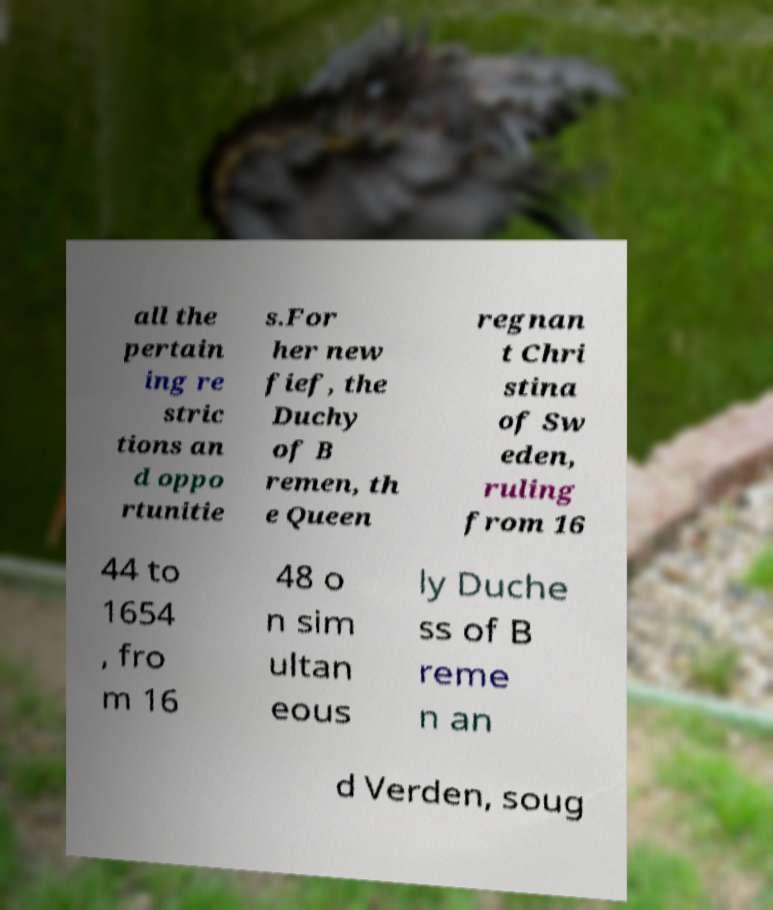Please identify and transcribe the text found in this image. all the pertain ing re stric tions an d oppo rtunitie s.For her new fief, the Duchy of B remen, th e Queen regnan t Chri stina of Sw eden, ruling from 16 44 to 1654 , fro m 16 48 o n sim ultan eous ly Duche ss of B reme n an d Verden, soug 